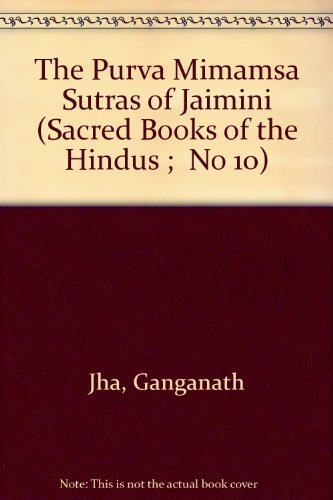What can you infer about the book's audience or readership based on its cover? The book's cover, with its simple and formal design, suggests it is intended for serious students and scholars of philosophy, religion, and Indology. The 'Sacred Books of the Hindus' series implies a pedagogical collection, likely used in academic settings or by those with a strong interest in Hindu scriptures and philosophical texts. 